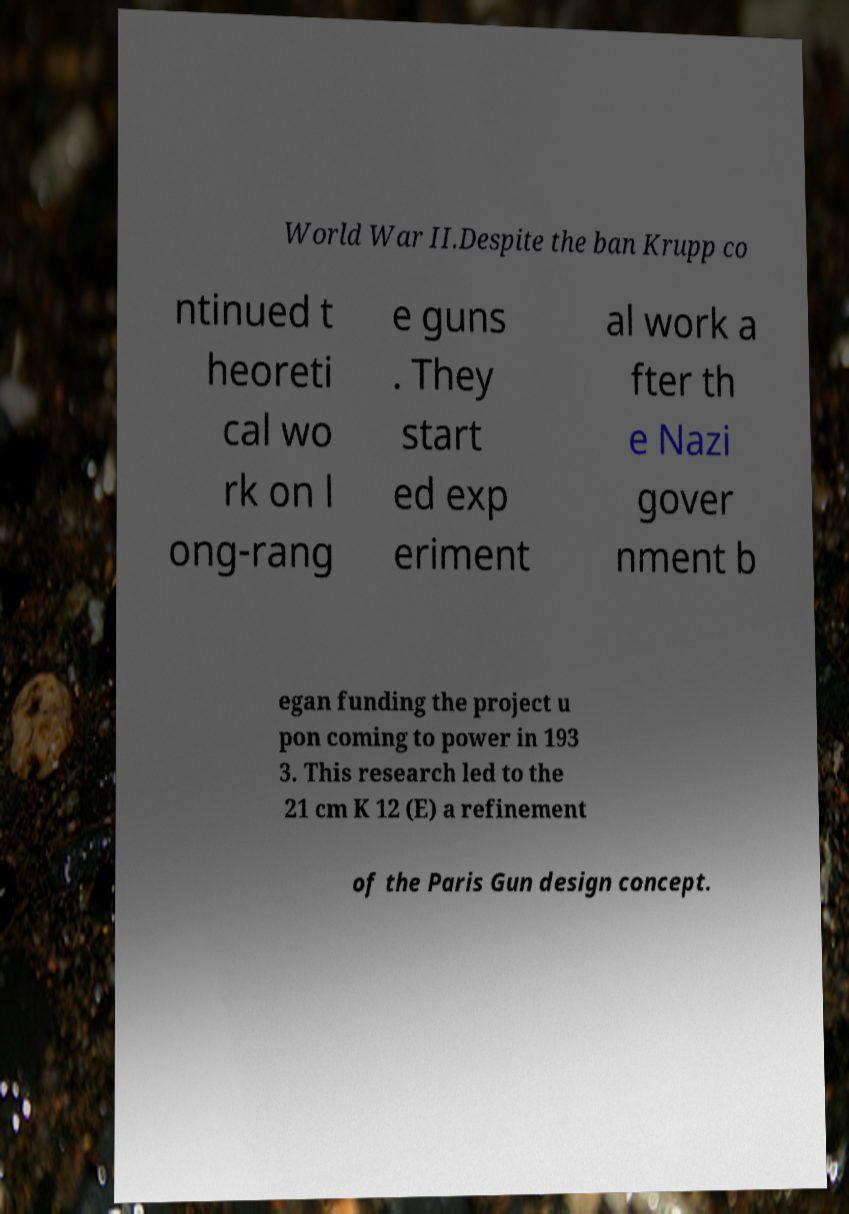Please identify and transcribe the text found in this image. World War II.Despite the ban Krupp co ntinued t heoreti cal wo rk on l ong-rang e guns . They start ed exp eriment al work a fter th e Nazi gover nment b egan funding the project u pon coming to power in 193 3. This research led to the 21 cm K 12 (E) a refinement of the Paris Gun design concept. 